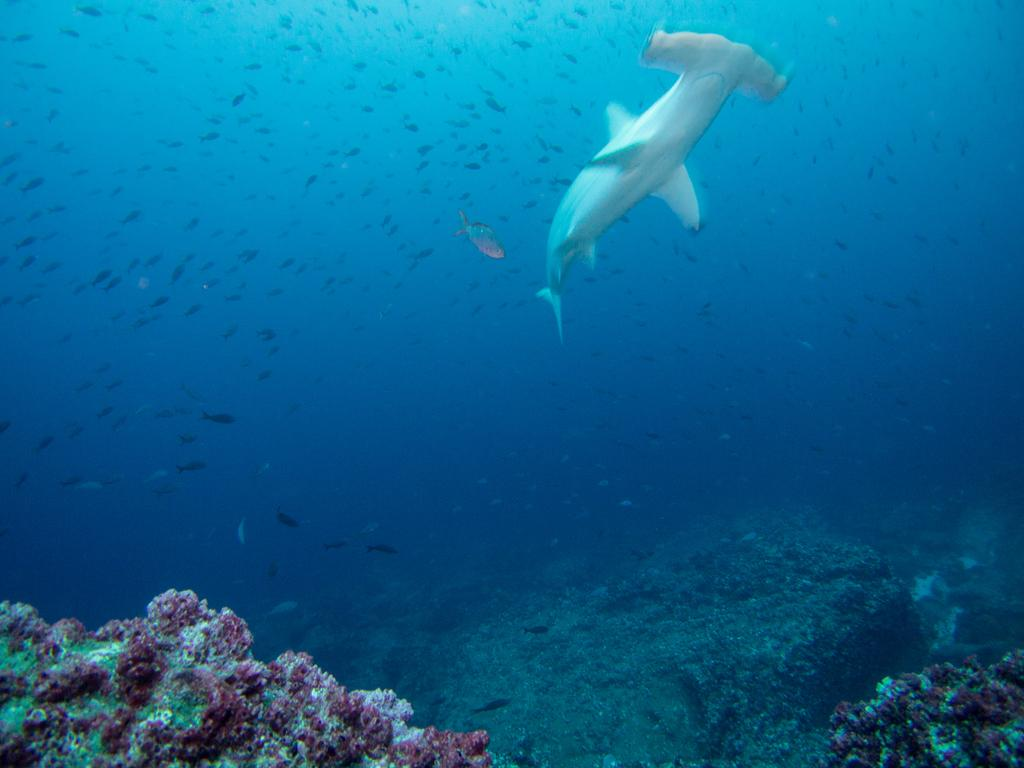What type of environment is depicted in the image? The image shows an underwater scene. What can be seen in the water in the image? There is sea water visible in the image. What type of fish can be seen in the image? There is a white color catfish and small fishes in the image. What is present at the bottom of the image? There are coral rocks at the bottom of the image. How does the man wash his clothes in the image? There is no man present in the image, and therefore no clothes washing can be observed. 